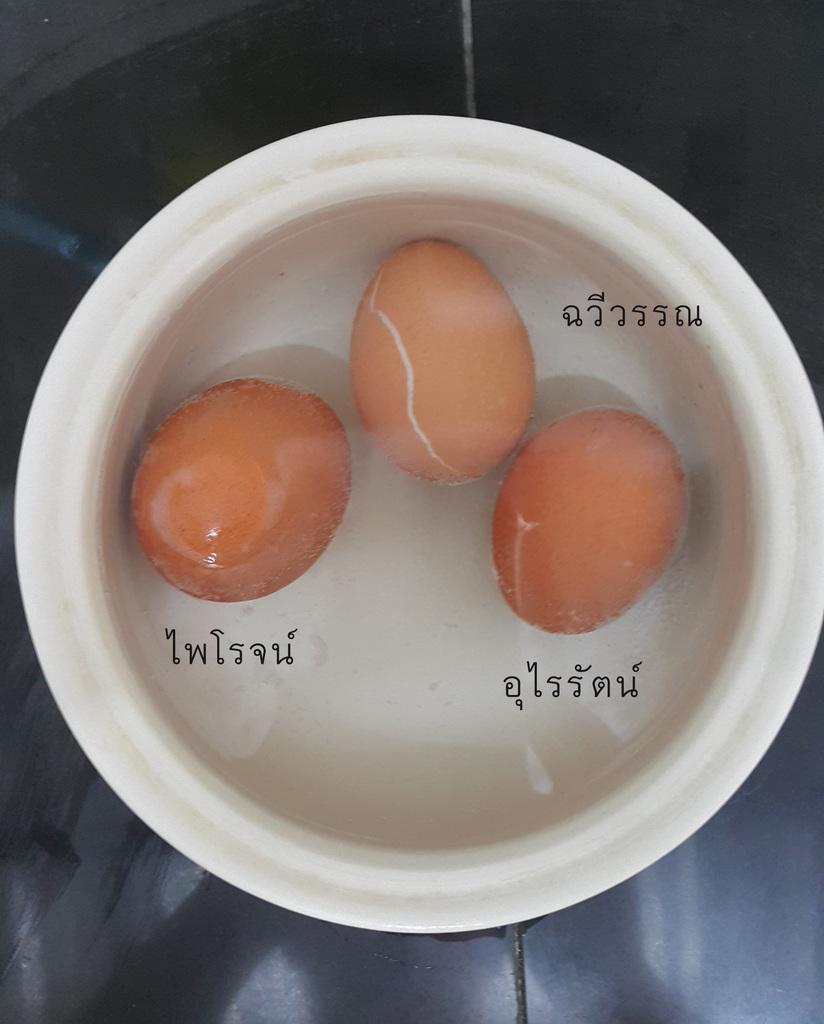What is in the bowl that is visible in the image? There are eggs and water in the bowl. What is the purpose of the water in the bowl? The water is likely used for boiling or cooking the eggs. What can be seen in the background of the image? There is a surface visible in the background of the image. Is there any additional information about the image itself? Yes, there is a watermark on the image. What type of town is visible in the background of the image? There is no town visible in the background of the image; it only shows a surface. Can you tell me the size of the fish in the bowl? There are no fish present in the bowl; it contains eggs and water. 